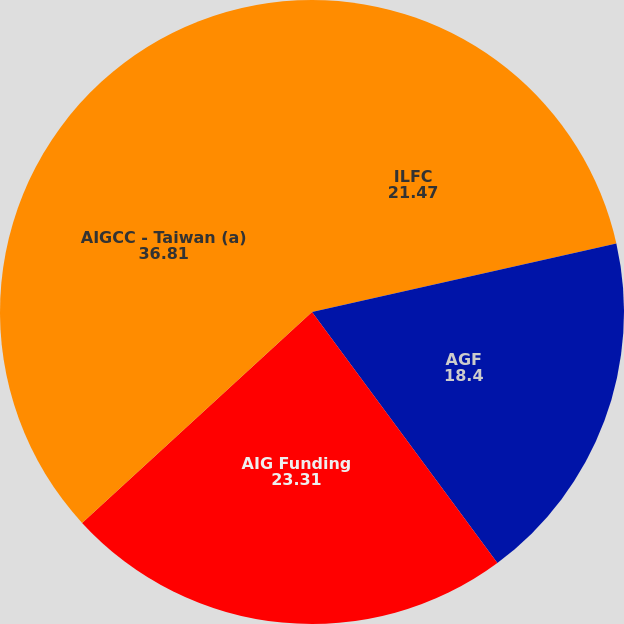Convert chart. <chart><loc_0><loc_0><loc_500><loc_500><pie_chart><fcel>ILFC<fcel>AGF<fcel>AIG Funding<fcel>AIGCC - Taiwan (a)<nl><fcel>21.47%<fcel>18.4%<fcel>23.31%<fcel>36.81%<nl></chart> 